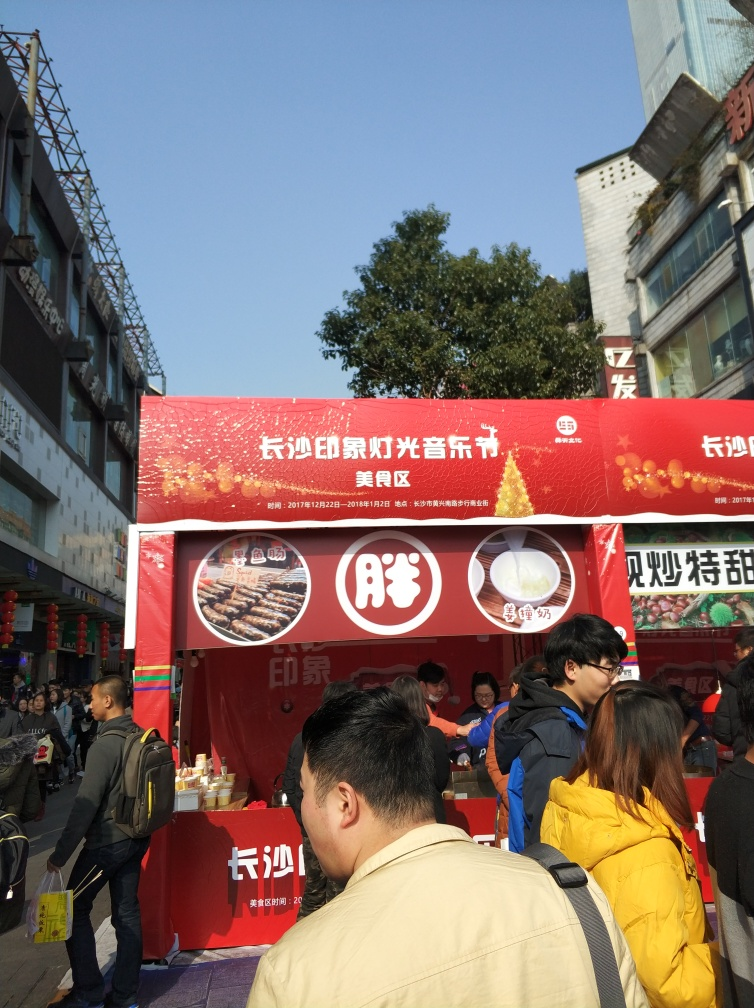What's the atmosphere like at this place? The atmosphere appears lively and busy, with numerous customers gathered around the stall, likely indicating the food is popular and the location is well-frequented. 